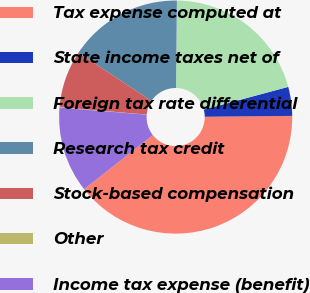<chart> <loc_0><loc_0><loc_500><loc_500><pie_chart><fcel>Tax expense computed at<fcel>State income taxes net of<fcel>Foreign tax rate differential<fcel>Research tax credit<fcel>Stock-based compensation<fcel>Other<fcel>Income tax expense (benefit)<nl><fcel>39.54%<fcel>4.01%<fcel>20.66%<fcel>15.86%<fcel>7.96%<fcel>0.06%<fcel>11.91%<nl></chart> 